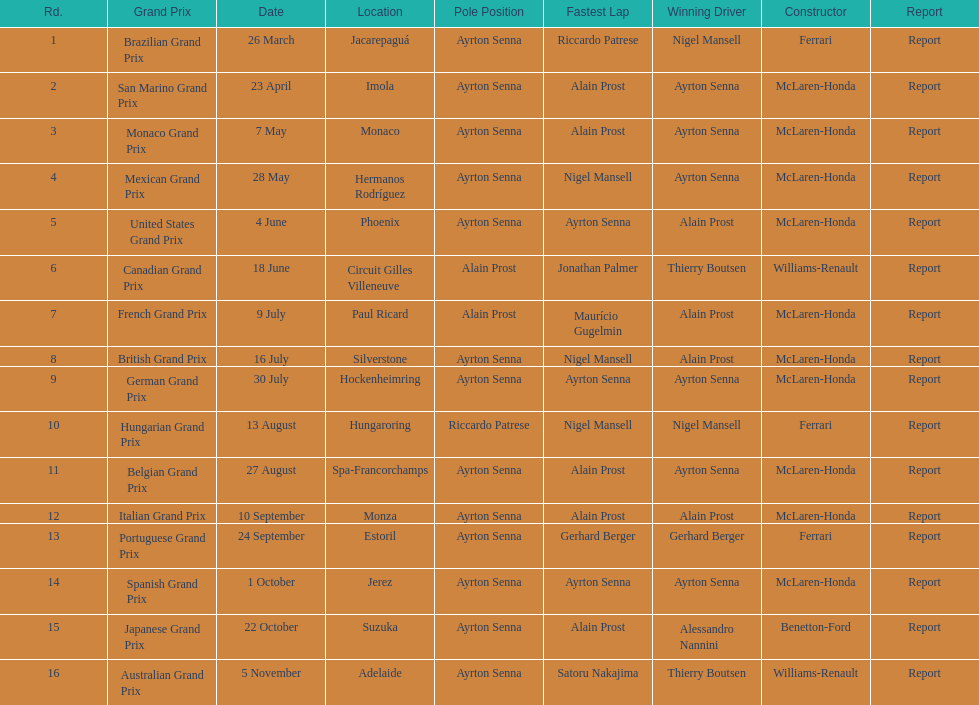What grand prix took place before the san marino grand prix? Brazilian Grand Prix. 